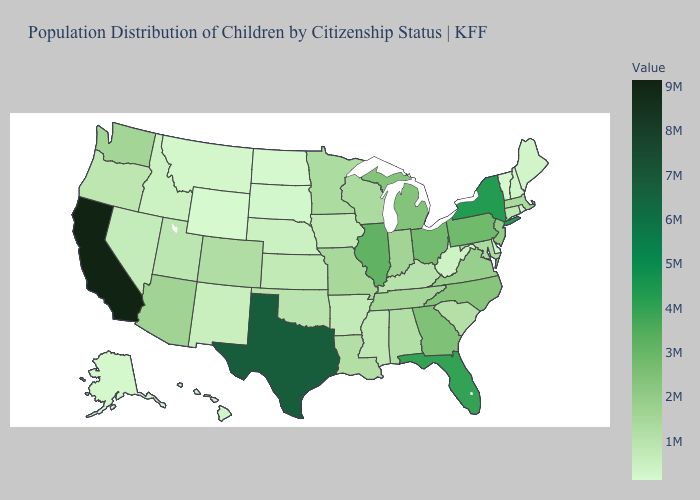Among the states that border Maine , which have the highest value?
Short answer required. New Hampshire. Does Hawaii have the highest value in the USA?
Quick response, please. No. Is the legend a continuous bar?
Answer briefly. Yes. Does the map have missing data?
Keep it brief. No. Which states hav the highest value in the South?
Be succinct. Texas. Which states have the highest value in the USA?
Concise answer only. California. 